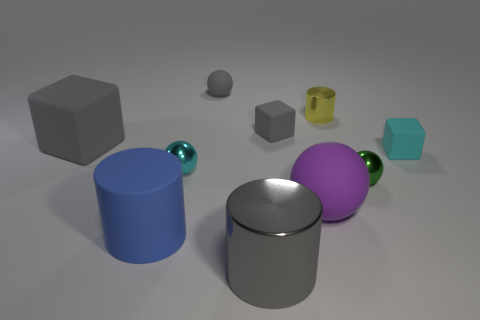What number of small things are either gray balls or metal things?
Provide a short and direct response. 4. How many other things are the same color as the large rubber sphere?
Your answer should be compact. 0. There is a small metallic thing behind the cube that is right of the large purple thing; how many small spheres are to the left of it?
Your answer should be compact. 2. There is a metal sphere that is to the left of the yellow cylinder; does it have the same size as the big matte block?
Offer a terse response. No. Is the number of small rubber objects left of the yellow metallic cylinder less than the number of shiny things in front of the blue matte cylinder?
Ensure brevity in your answer.  No. Is the color of the large metal cylinder the same as the small cylinder?
Offer a very short reply. No. Are there fewer small cyan spheres that are behind the tiny cyan block than small blue rubber cubes?
Make the answer very short. No. What is the material of the small cube that is the same color as the big rubber cube?
Provide a succinct answer. Rubber. Does the big gray cylinder have the same material as the purple thing?
Your response must be concise. No. What number of cyan things have the same material as the small cylinder?
Make the answer very short. 1. 